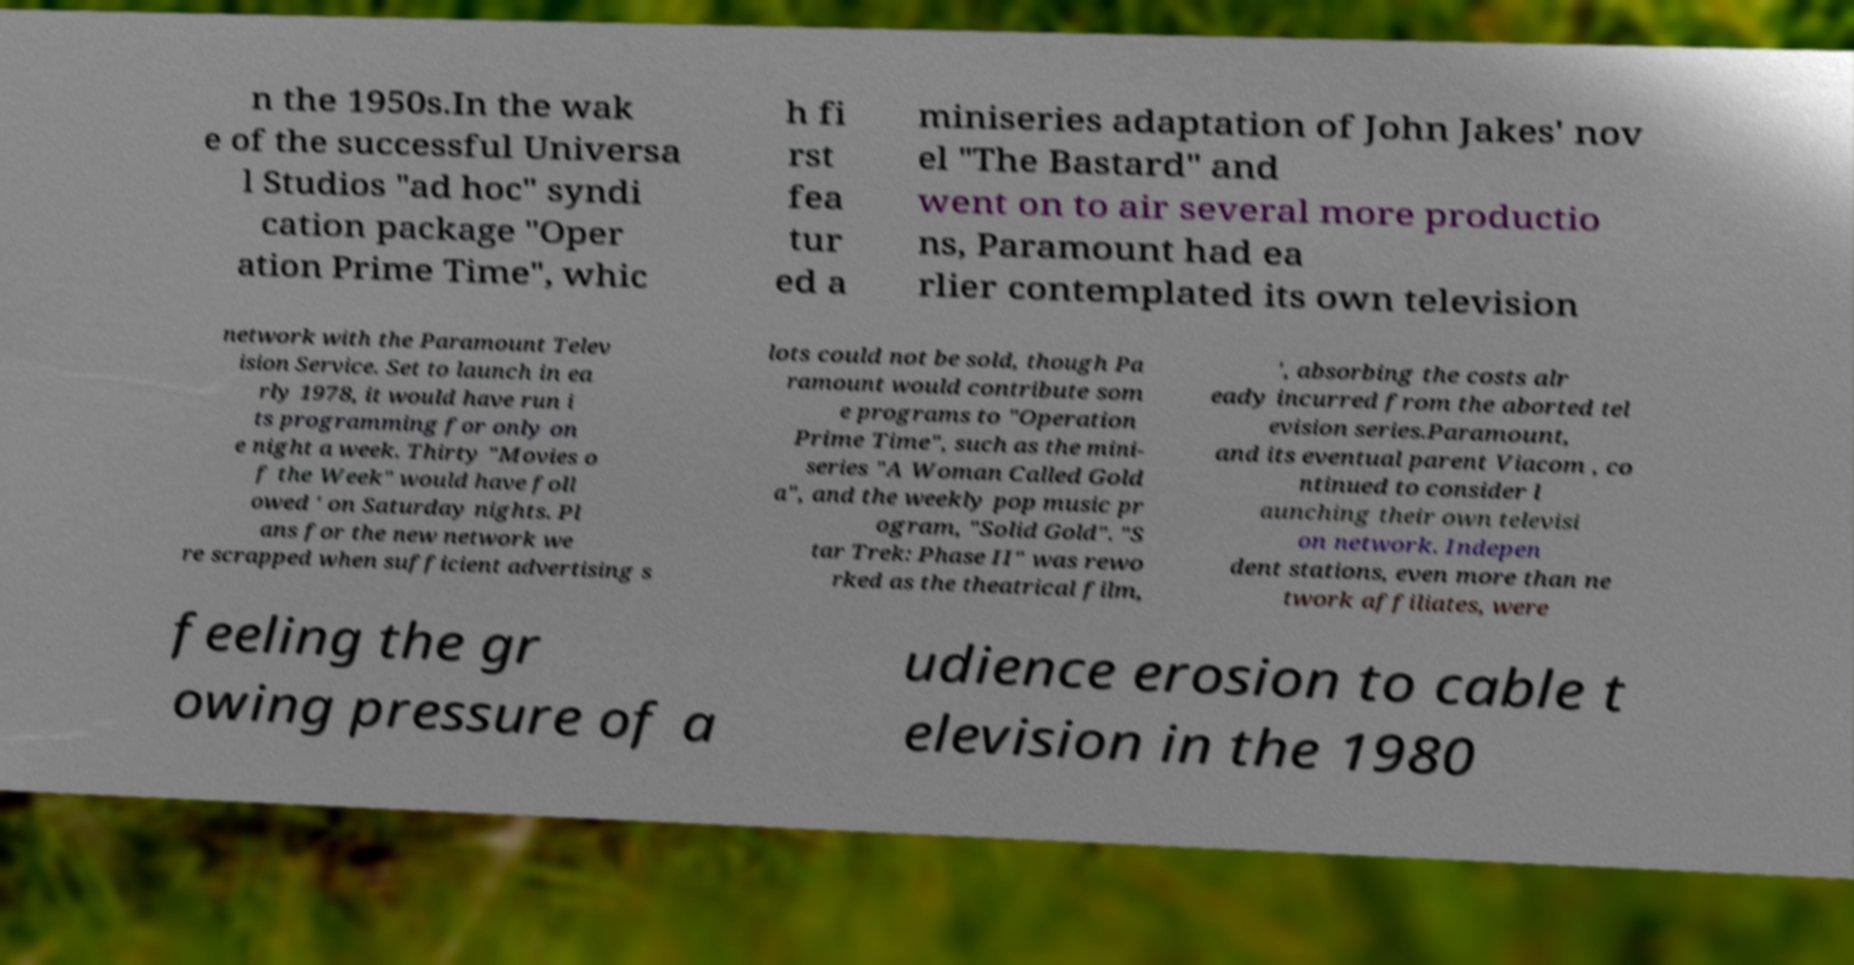Please identify and transcribe the text found in this image. n the 1950s.In the wak e of the successful Universa l Studios "ad hoc" syndi cation package "Oper ation Prime Time", whic h fi rst fea tur ed a miniseries adaptation of John Jakes' nov el "The Bastard" and went on to air several more productio ns, Paramount had ea rlier contemplated its own television network with the Paramount Telev ision Service. Set to launch in ea rly 1978, it would have run i ts programming for only on e night a week. Thirty "Movies o f the Week" would have foll owed ' on Saturday nights. Pl ans for the new network we re scrapped when sufficient advertising s lots could not be sold, though Pa ramount would contribute som e programs to "Operation Prime Time", such as the mini- series "A Woman Called Gold a", and the weekly pop music pr ogram, "Solid Gold". "S tar Trek: Phase II" was rewo rked as the theatrical film, ', absorbing the costs alr eady incurred from the aborted tel evision series.Paramount, and its eventual parent Viacom , co ntinued to consider l aunching their own televisi on network. Indepen dent stations, even more than ne twork affiliates, were feeling the gr owing pressure of a udience erosion to cable t elevision in the 1980 